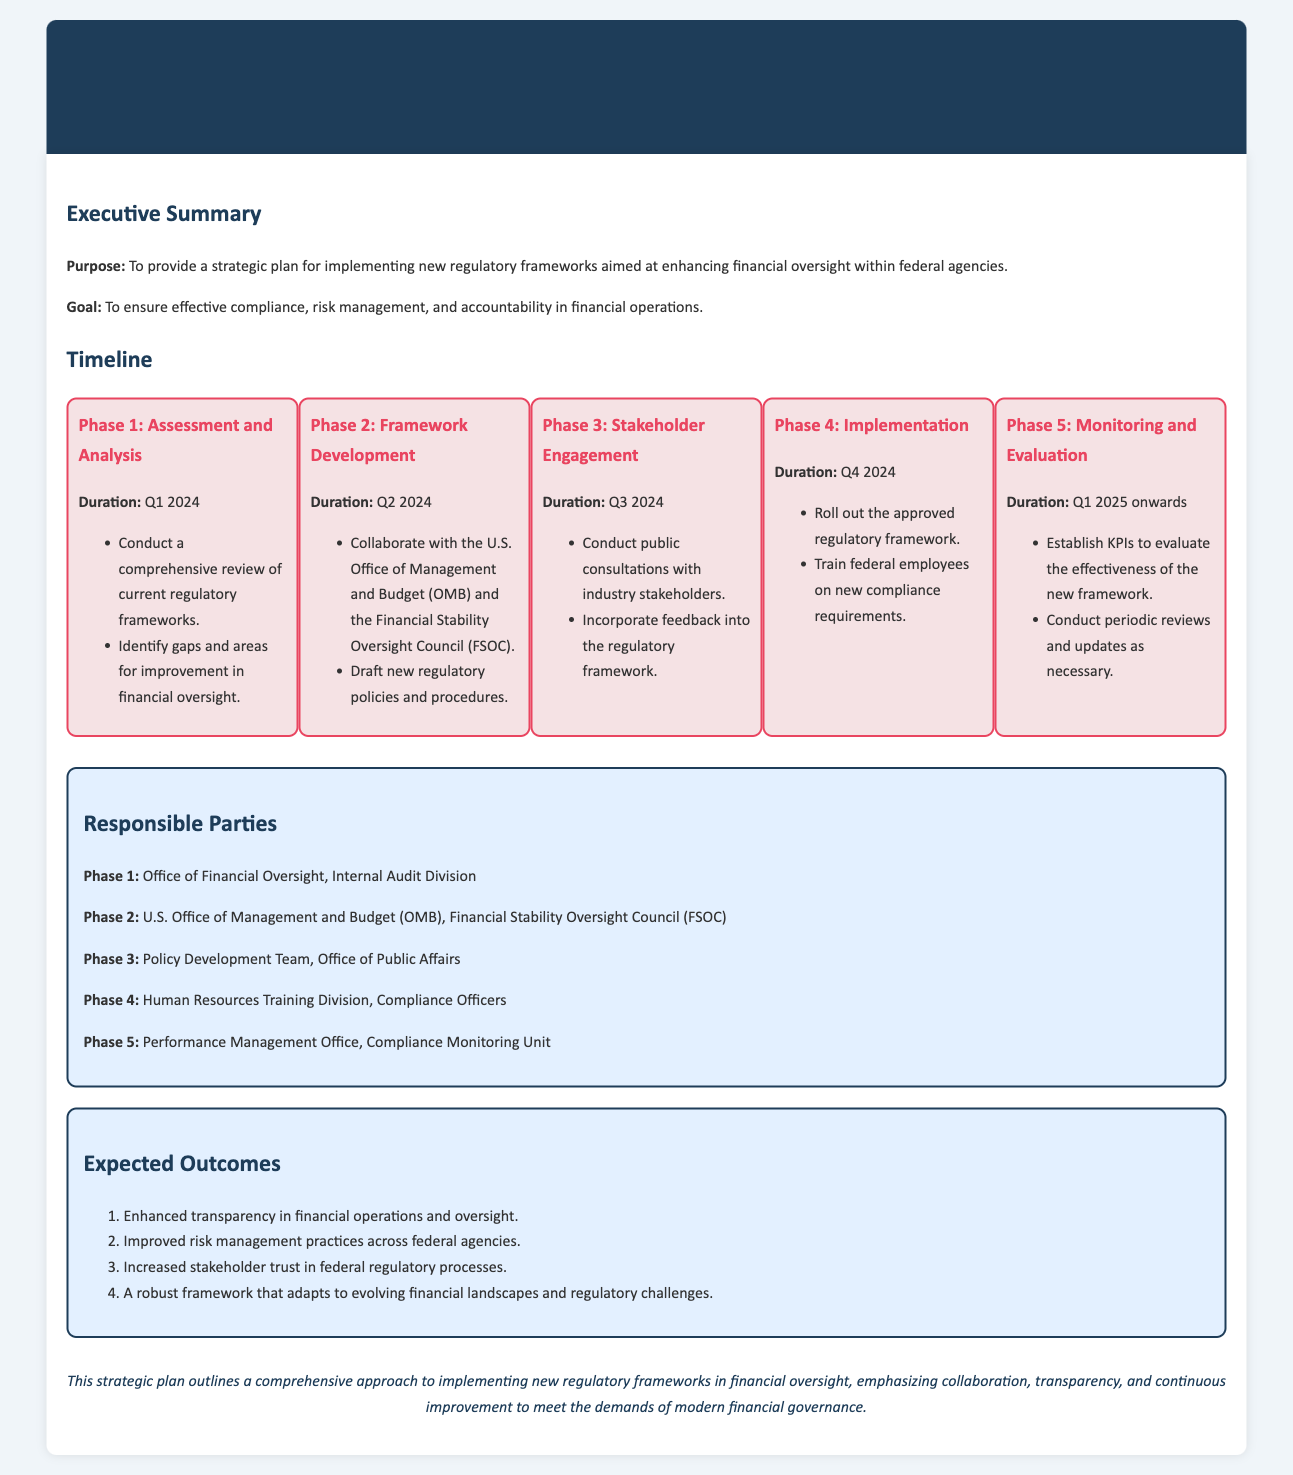What is the main goal of the strategic plan? The goal is outlined in the executive summary as ensuring effective compliance, risk management, and accountability in financial operations.
Answer: To ensure effective compliance, risk management, and accountability in financial operations Which agency is responsible for Phase 2? The document identifies the U.S. Office of Management and Budget (OMB) and the Financial Stability Oversight Council (FSOC) as responsible parties for Phase 2.
Answer: U.S. Office of Management and Budget (OMB), Financial Stability Oversight Council (FSOC) What is the duration of Phase 3? Phase 3 is outlined in the timeline section as occurring in Q3 2024.
Answer: Q3 2024 List one expected outcome from the implementation of the new frameworks. The expected outcomes section lists several outcomes, one being enhanced transparency in financial operations and oversight.
Answer: Enhanced transparency in financial operations and oversight What is the first phase of the strategic plan? The strategic plan outlines the first phase as Assessment and Analysis in the timeline section.
Answer: Assessment and Analysis 